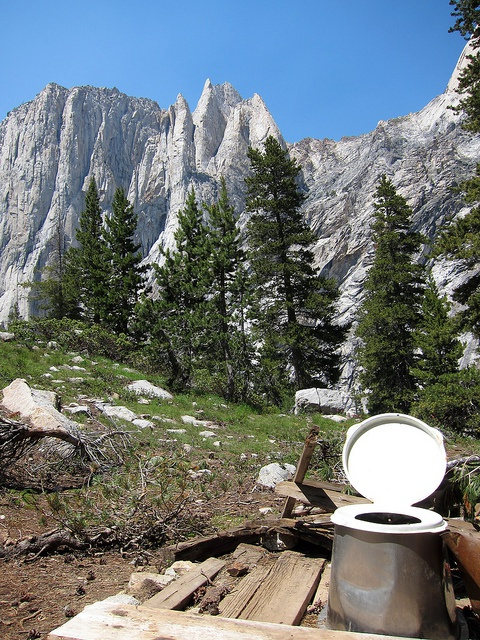Describe the objects in this image and their specific colors. I can see a toilet in lightblue, white, black, gray, and darkgray tones in this image. 